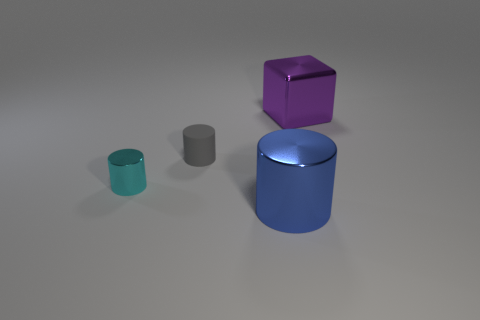There is a purple block; are there any purple objects to the left of it?
Your answer should be compact. No. Are there an equal number of blue shiny cylinders behind the big purple object and tiny objects that are behind the cyan shiny cylinder?
Give a very brief answer. No. There is a shiny cylinder that is in front of the cyan thing; is it the same size as the metallic cylinder that is behind the blue shiny object?
Make the answer very short. No. There is a thing that is in front of the cyan metallic cylinder behind the big cylinder right of the small matte thing; what shape is it?
Provide a short and direct response. Cylinder. Are there any other things that have the same material as the small gray cylinder?
Provide a succinct answer. No. What size is the other metal thing that is the same shape as the tiny metal thing?
Offer a very short reply. Large. There is a cylinder that is left of the blue cylinder and in front of the tiny gray matte cylinder; what color is it?
Ensure brevity in your answer.  Cyan. Is the purple object made of the same material as the cylinder in front of the tiny cyan metallic cylinder?
Ensure brevity in your answer.  Yes. Are there fewer tiny metallic things right of the purple metal block than small gray matte cylinders?
Your answer should be compact. Yes. How many other objects are there of the same shape as the purple metallic thing?
Offer a terse response. 0. 